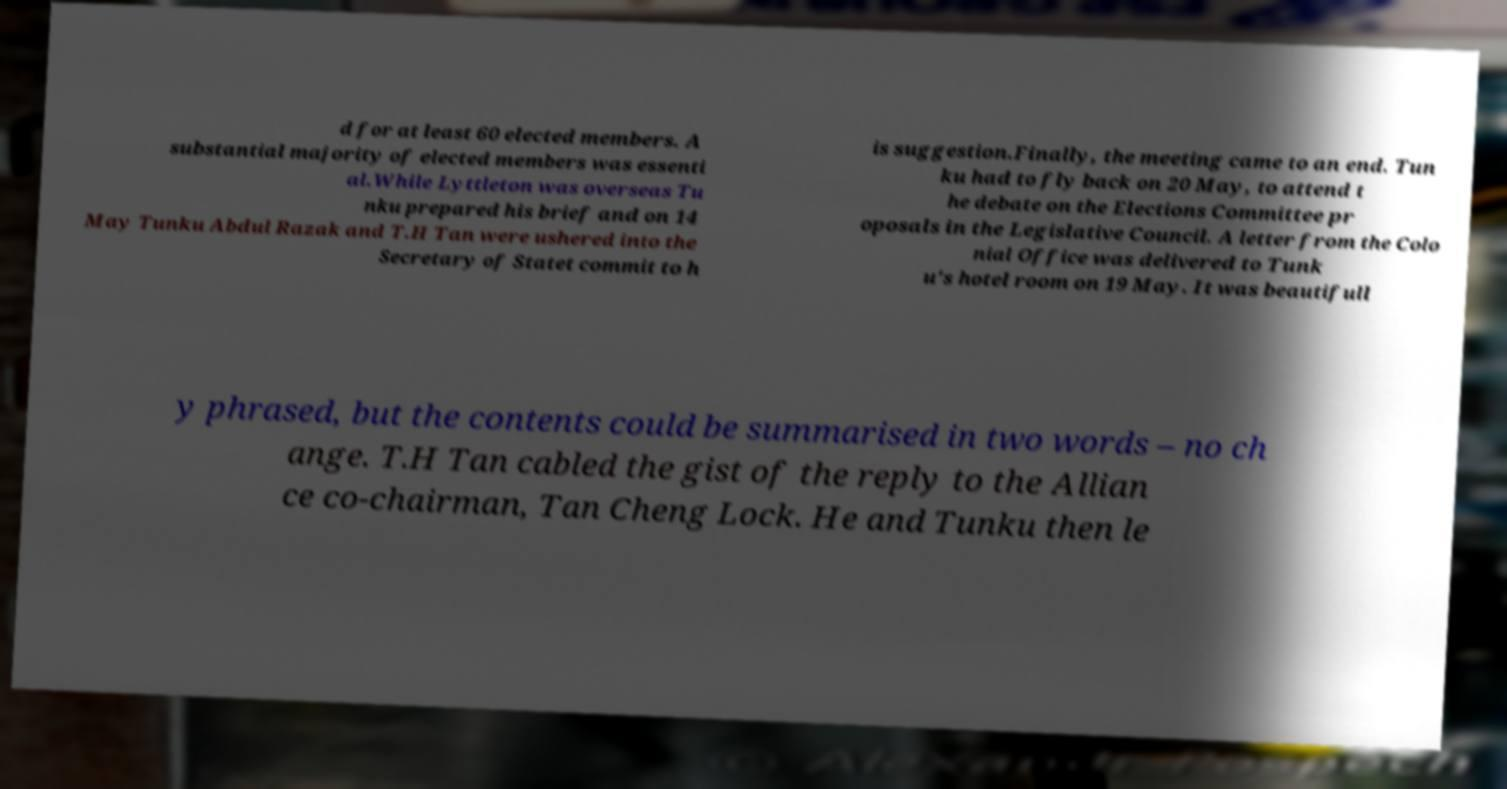For documentation purposes, I need the text within this image transcribed. Could you provide that? d for at least 60 elected members. A substantial majority of elected members was essenti al.While Lyttleton was overseas Tu nku prepared his brief and on 14 May Tunku Abdul Razak and T.H Tan were ushered into the Secretary of Statet commit to h is suggestion.Finally, the meeting came to an end. Tun ku had to fly back on 20 May, to attend t he debate on the Elections Committee pr oposals in the Legislative Council. A letter from the Colo nial Office was delivered to Tunk u's hotel room on 19 May. It was beautifull y phrased, but the contents could be summarised in two words – no ch ange. T.H Tan cabled the gist of the reply to the Allian ce co-chairman, Tan Cheng Lock. He and Tunku then le 